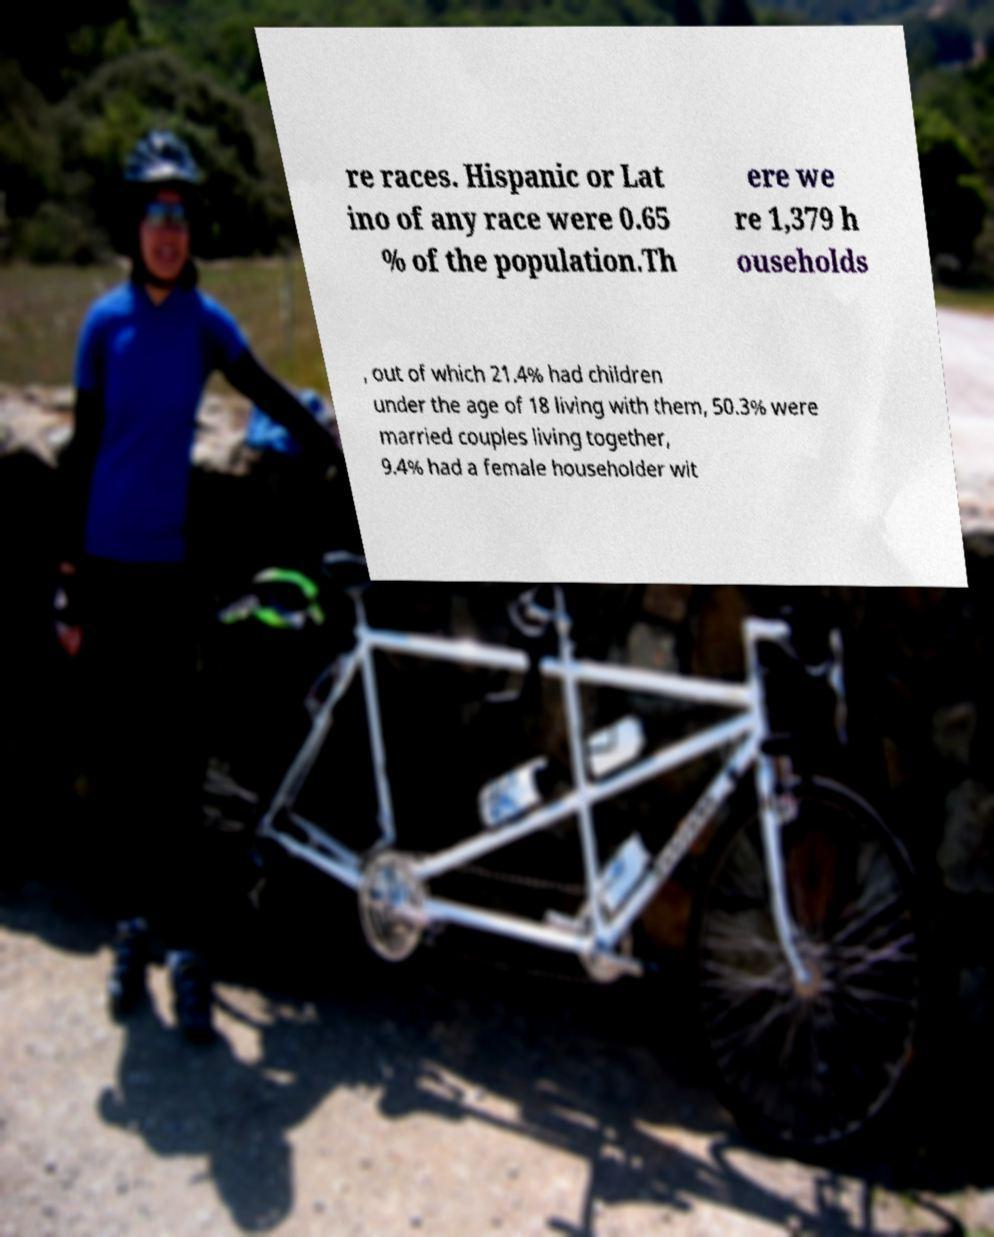Can you accurately transcribe the text from the provided image for me? re races. Hispanic or Lat ino of any race were 0.65 % of the population.Th ere we re 1,379 h ouseholds , out of which 21.4% had children under the age of 18 living with them, 50.3% were married couples living together, 9.4% had a female householder wit 